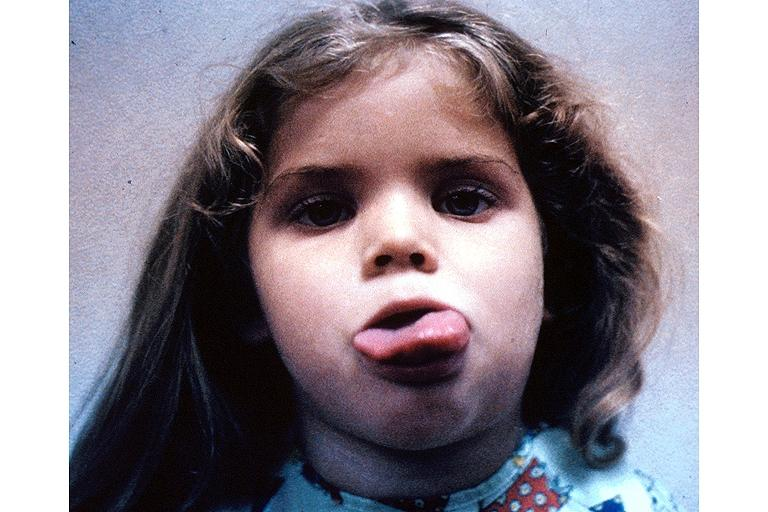does this image show neurofibromatosis-macroglossi?
Answer the question using a single word or phrase. Yes 